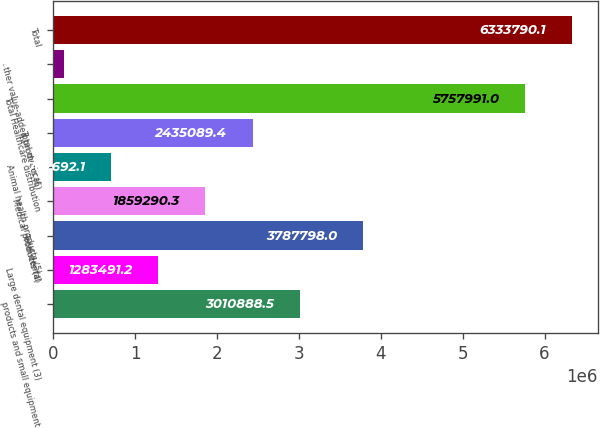Convert chart to OTSL. <chart><loc_0><loc_0><loc_500><loc_500><bar_chart><fcel>products and small equipment<fcel>Large dental equipment (3)<fcel>Total dental<fcel>Medical products (4)<fcel>Animal health products (5)<fcel>Total medical<fcel>Total Healthcare distribution<fcel>other value-added products (6)<fcel>Total<nl><fcel>3.01089e+06<fcel>1.28349e+06<fcel>3.7878e+06<fcel>1.85929e+06<fcel>707692<fcel>2.43509e+06<fcel>5.75799e+06<fcel>131893<fcel>6.33379e+06<nl></chart> 